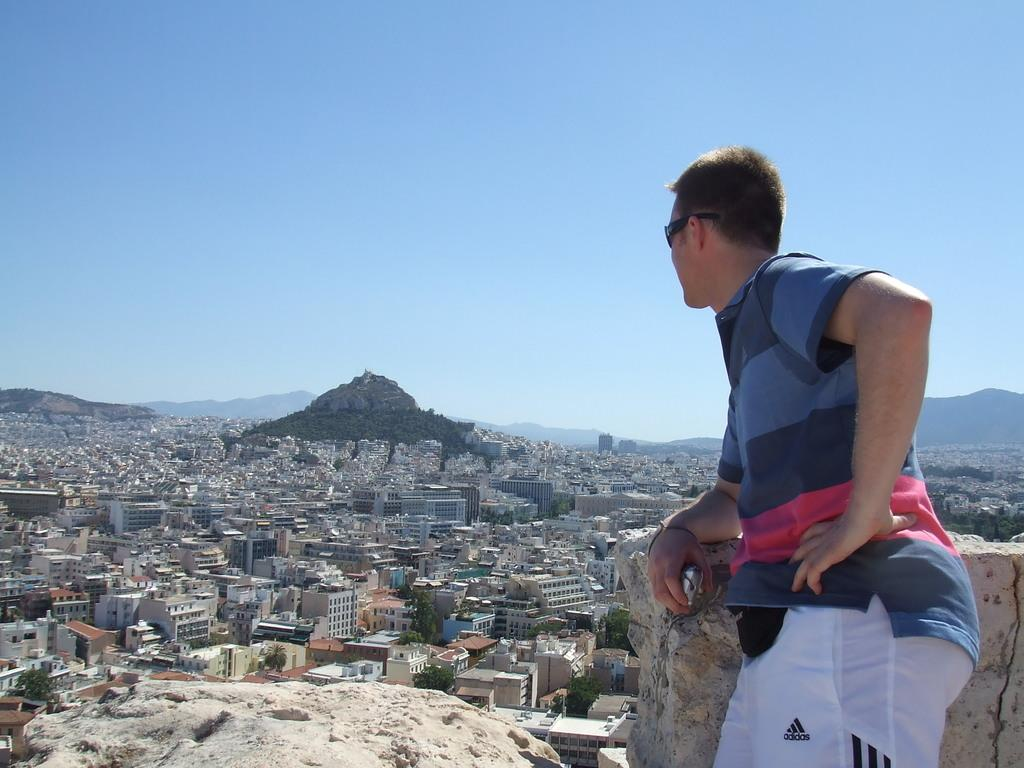What type of structures are visible in the image? There are buildings in the image. What geographical feature is located in the middle of the image? There is a hill in the middle of the image. What is visible at the top of the image? The sky is visible at the top of the image. Where is the person located in the image? The person is standing on the right side of the image. What is the person standing in front of? The person is standing in front of a wall. What color is the party taking place on the left side of the image? There is no party present in the image, and therefore no such event can be observed. On which side of the person is the color located in the image? There is no mention of color being associated with a specific side of the person in the image. 